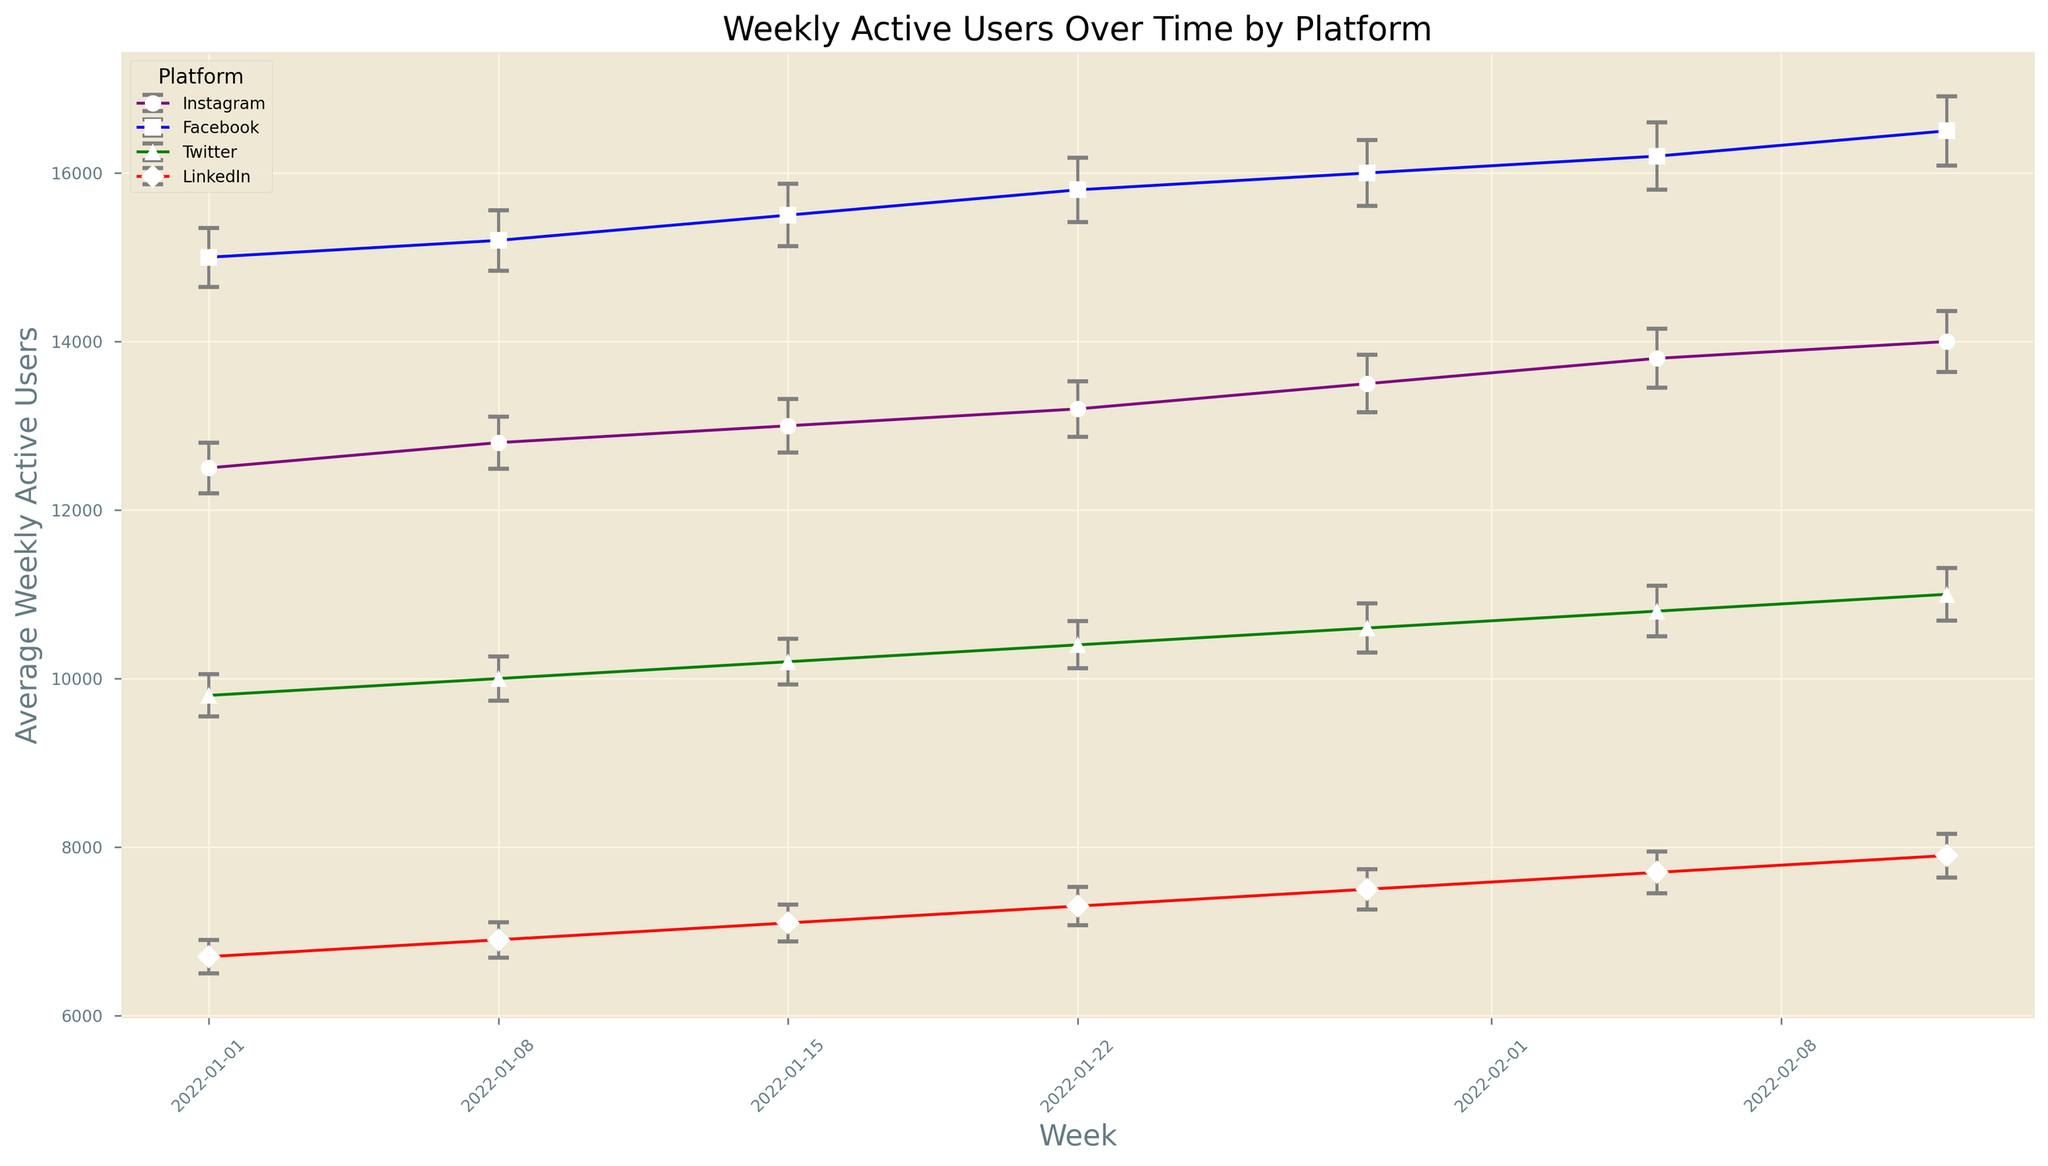Which platform has the highest average Weekly Active Users (WAU) on 2022-01-01? On 2022-01-01, Facebook has the highest average WAU. You can see this by comparing the data points for all platforms on this date and observing that Facebook's mark is the highest.
Answer: Facebook What can you say about the trend of LinkedIn's Weekly Active Users over the displayed weeks? Observing the increasing trend in LinkedIn's data points over the weeks suggests that the average WAU for LinkedIn rises consistently from the start to the end of the displayed period.
Answer: Increasing How does the error margin for Instagram on 2022-02-12 compare to the error margin for Twitter on the same date? On 2022-02-12, you can see that the error margin for Instagram is higher than that of Twitter. Instagram has an error margin of 360, while Twitter has an error margin of 310.
Answer: Higher Which platform has the smallest increase in average Weekly Active Users from 2022-01-01 to 2022-02-12? Calculating the difference in average WAU from 2022-01-01 to 2022-02-12 for each platform: 
- Instagram: 14000 - 12500 = 1500 
- Facebook: 16500 - 15000 = 1500 
- Twitter: 11000 - 9800 = 1200 
- LinkedIn: 7900 - 6700 = 1200 
Thus, LinkedIn and Twitter have the smallest increase of 1200.
Answer: LinkedIn, Twitter Comparing the error margins, which platform shows the most variation over the period? Observing each platform's error margins over all weeks indicates that Facebook has the most considerable variation, with error margins from 350 to 410. The others show smaller ranges.
Answer: Facebook What is the average number of Weekly Active Users for Facebook across all the displayed weeks? Summing Facebook's average WAU values across the weeks: 15000 + 15200 + 15500 + 15800 + 16000 + 16200 + 16500 = 110200, then dividing by the number of weeks (7), we get 110200 / 7 = 15742.86.
Answer: 15742.86 How do the user trends between Instagram and Facebook differ from 2022-01-01 to 2022-02-12? Both Instagram and Facebook show an increasing trend in WAU over the weeks, but Facebook's increase is overall more gradual and steady, whereas Instagram shows a sharper increase, particularly towards the last weeks.
Answer: Different increase rates Which platform's data points show the least overlapping error margins with other platforms? Observing the error bars, LinkedIn has the least overlapping error margins with other platforms, as its user base is significantly lower than Facebook, Twitter, and Instagram.
Answer: LinkedIn Between 2022-01-15 and 2022-01-22, which platform experienced the largest increase in average Weekly Active Users? Examining the change in average WAU for each platform between these two dates:
- Instagram: 13200 - 13000 = 200
- Facebook: 15800 - 15500 = 300
- Twitter: 10400 - 10200 = 200
- LinkedIn: 7300 - 7100 = 200
Facebook experienced the largest increase with a rise of 300.
Answer: Facebook 